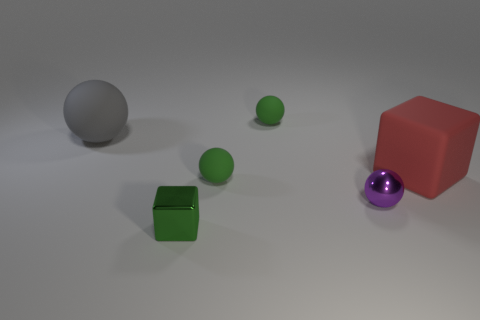Subtract all big gray spheres. How many spheres are left? 3 Add 2 small green things. How many objects exist? 8 Subtract all red blocks. How many blocks are left? 1 Subtract 1 balls. How many balls are left? 3 Subtract all tiny gray rubber cylinders. Subtract all large red rubber things. How many objects are left? 5 Add 4 purple objects. How many purple objects are left? 5 Add 3 large purple cylinders. How many large purple cylinders exist? 3 Subtract 0 blue cylinders. How many objects are left? 6 Subtract all cubes. How many objects are left? 4 Subtract all red balls. Subtract all gray cubes. How many balls are left? 4 